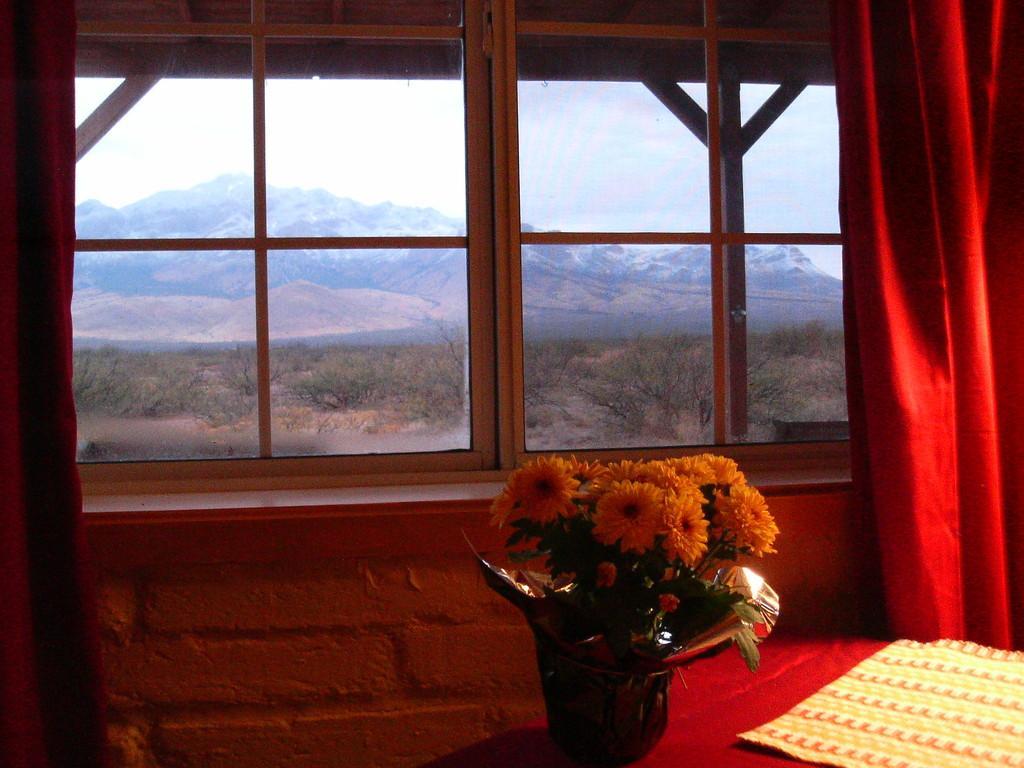Please provide a concise description of this image. This picture is inside view of a room. We can see windows, glass, curtain, wall are there. At the bottom of the image we can see a table. On the table we can see cloth, flower pot are there. In the background of the image we can see hills, trees, ground are there. At the top of the image clouds are present in the sky. 